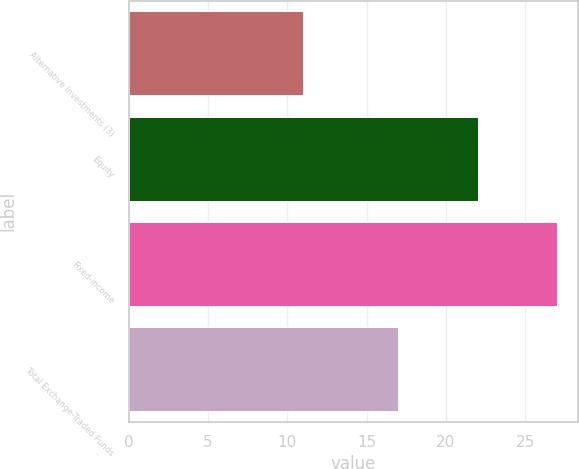Convert chart to OTSL. <chart><loc_0><loc_0><loc_500><loc_500><bar_chart><fcel>Alternative Investments (3)<fcel>Equity<fcel>Fixed-income<fcel>Total Exchange-Traded Funds<nl><fcel>11<fcel>22<fcel>27<fcel>17<nl></chart> 